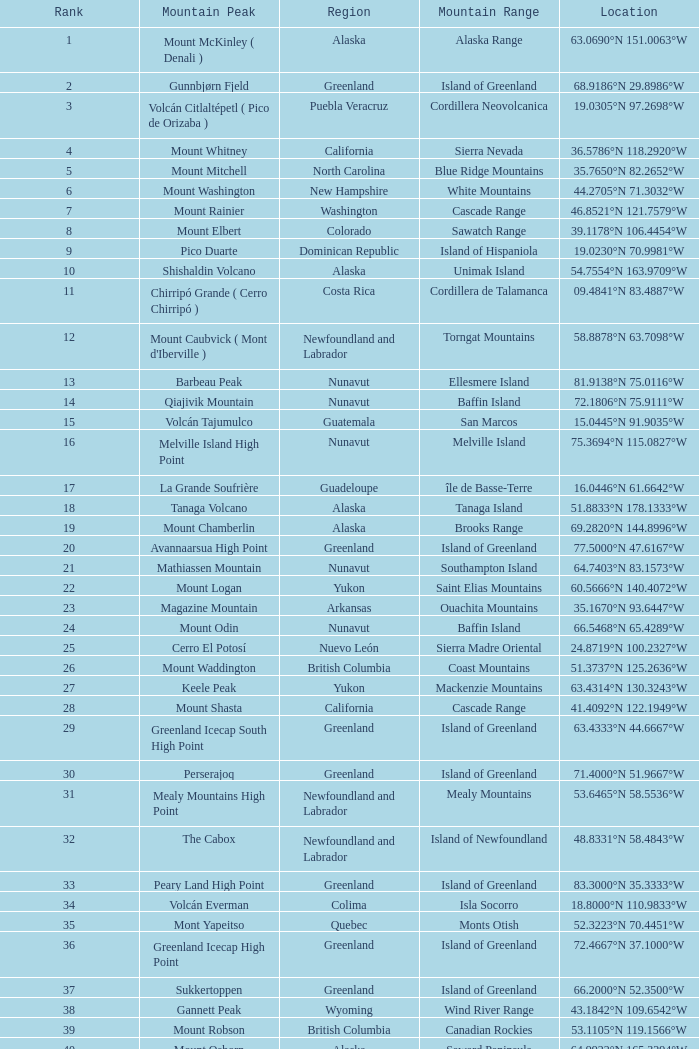Name the Region with a Mountain Peak of dillingham high point? Alaska. 